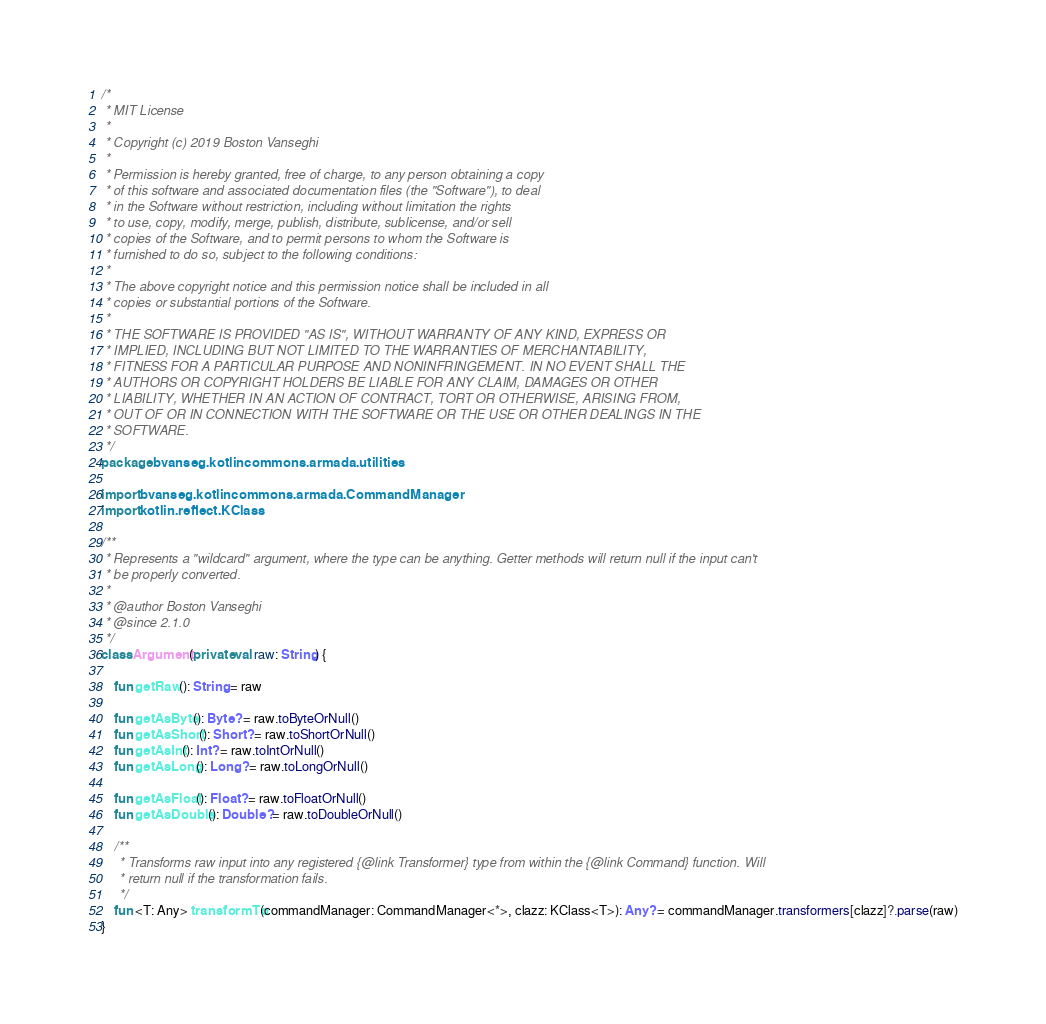Convert code to text. <code><loc_0><loc_0><loc_500><loc_500><_Kotlin_>/*
 * MIT License
 *
 * Copyright (c) 2019 Boston Vanseghi
 *
 * Permission is hereby granted, free of charge, to any person obtaining a copy
 * of this software and associated documentation files (the "Software"), to deal
 * in the Software without restriction, including without limitation the rights
 * to use, copy, modify, merge, publish, distribute, sublicense, and/or sell
 * copies of the Software, and to permit persons to whom the Software is
 * furnished to do so, subject to the following conditions:
 *
 * The above copyright notice and this permission notice shall be included in all
 * copies or substantial portions of the Software.
 *
 * THE SOFTWARE IS PROVIDED "AS IS", WITHOUT WARRANTY OF ANY KIND, EXPRESS OR
 * IMPLIED, INCLUDING BUT NOT LIMITED TO THE WARRANTIES OF MERCHANTABILITY,
 * FITNESS FOR A PARTICULAR PURPOSE AND NONINFRINGEMENT. IN NO EVENT SHALL THE
 * AUTHORS OR COPYRIGHT HOLDERS BE LIABLE FOR ANY CLAIM, DAMAGES OR OTHER
 * LIABILITY, WHETHER IN AN ACTION OF CONTRACT, TORT OR OTHERWISE, ARISING FROM,
 * OUT OF OR IN CONNECTION WITH THE SOFTWARE OR THE USE OR OTHER DEALINGS IN THE
 * SOFTWARE.
 */
package bvanseg.kotlincommons.armada.utilities

import bvanseg.kotlincommons.armada.CommandManager
import kotlin.reflect.KClass

/**
 * Represents a "wildcard" argument, where the type can be anything. Getter methods will return null if the input can't
 * be properly converted.
 *
 * @author Boston Vanseghi
 * @since 2.1.0
 */
class Argument(private val raw: String) {

    fun getRaw(): String = raw

    fun getAsByte(): Byte? = raw.toByteOrNull()
    fun getAsShort(): Short? = raw.toShortOrNull()
    fun getAsInt(): Int? = raw.toIntOrNull()
    fun getAsLong(): Long? = raw.toLongOrNull()

    fun getAsFloat(): Float? = raw.toFloatOrNull()
    fun getAsDouble(): Double? = raw.toDoubleOrNull()

    /**
     * Transforms raw input into any registered {@link Transformer} type from within the {@link Command} function. Will
     * return null if the transformation fails.
     */
    fun <T: Any> transformTo(commandManager: CommandManager<*>, clazz: KClass<T>): Any? = commandManager.transformers[clazz]?.parse(raw)
}</code> 